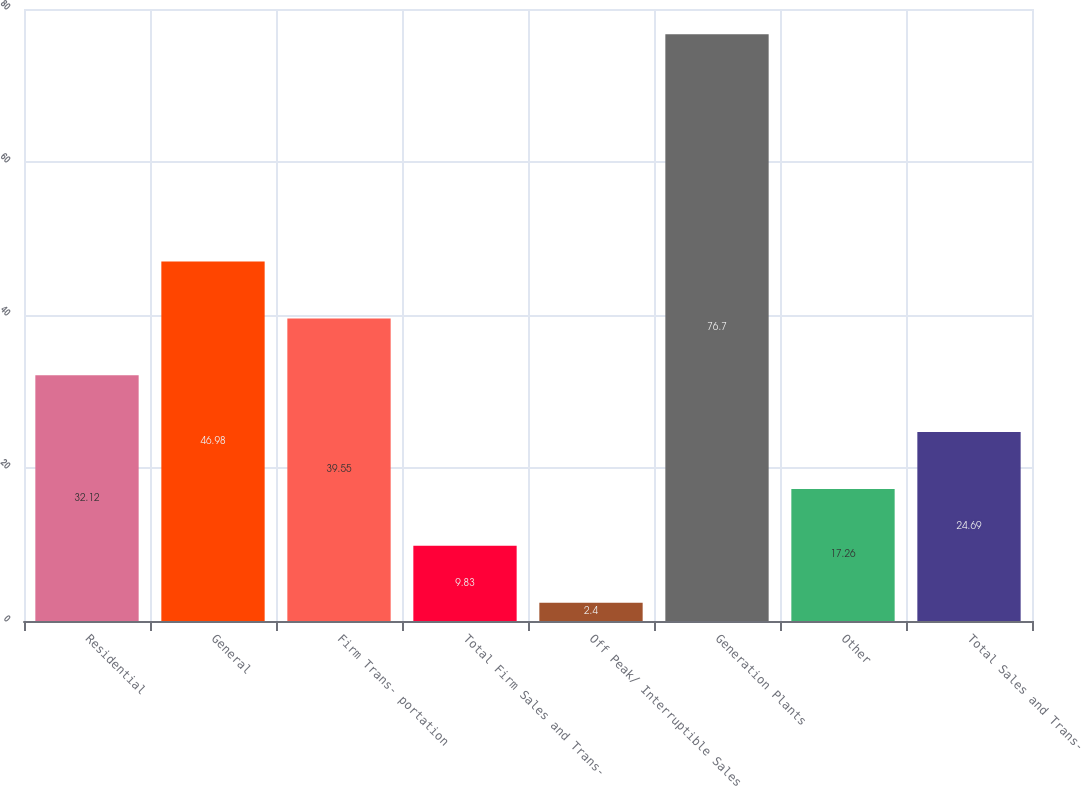Convert chart. <chart><loc_0><loc_0><loc_500><loc_500><bar_chart><fcel>Residential<fcel>General<fcel>Firm Trans- portation<fcel>Total Firm Sales and Trans-<fcel>Off Peak/ Interruptible Sales<fcel>Generation Plants<fcel>Other<fcel>Total Sales and Trans-<nl><fcel>32.12<fcel>46.98<fcel>39.55<fcel>9.83<fcel>2.4<fcel>76.7<fcel>17.26<fcel>24.69<nl></chart> 